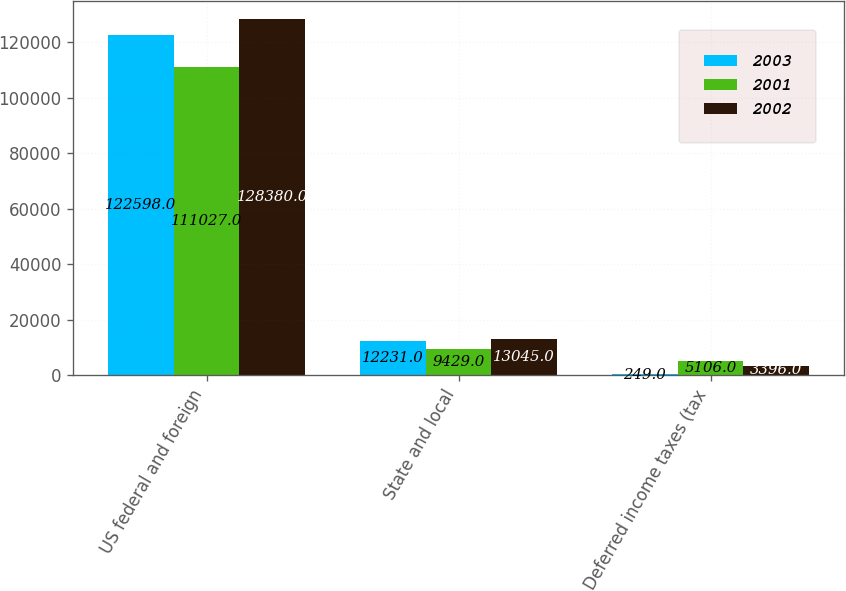Convert chart to OTSL. <chart><loc_0><loc_0><loc_500><loc_500><stacked_bar_chart><ecel><fcel>US federal and foreign<fcel>State and local<fcel>Deferred income taxes (tax<nl><fcel>2003<fcel>122598<fcel>12231<fcel>249<nl><fcel>2001<fcel>111027<fcel>9429<fcel>5106<nl><fcel>2002<fcel>128380<fcel>13045<fcel>3396<nl></chart> 